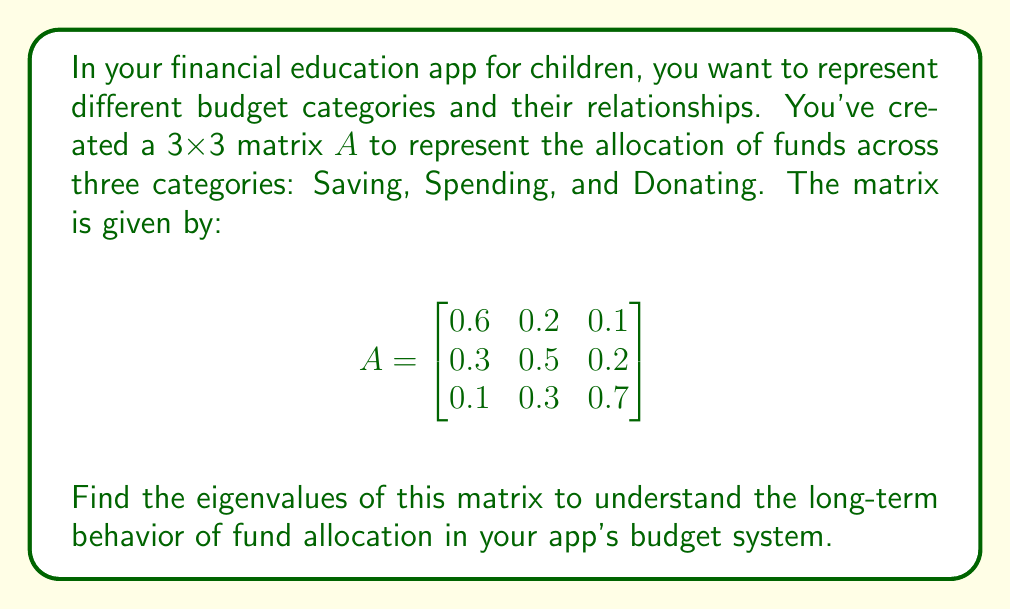Can you answer this question? To find the eigenvalues of matrix A, we need to solve the characteristic equation:

$$det(A - \lambda I) = 0$$

Where $\lambda$ represents the eigenvalues and I is the 3x3 identity matrix.

Step 1: Set up the characteristic equation:
$$\begin{vmatrix}
0.6 - \lambda & 0.2 & 0.1 \\
0.3 & 0.5 - \lambda & 0.2 \\
0.1 & 0.3 & 0.7 - \lambda
\end{vmatrix} = 0$$

Step 2: Expand the determinant:
$$(0.6 - \lambda)[(0.5 - \lambda)(0.7 - \lambda) - 0.06] - 0.2[0.3(0.7 - \lambda) - 0.02] + 0.1[0.3(0.5 - \lambda) - 0.06] = 0$$

Step 3: Simplify:
$$-\lambda^3 + 1.8\lambda^2 - 0.98\lambda + 0.16 = 0$$

Step 4: Solve the cubic equation. This can be done using the cubic formula or numerical methods. Using a computer algebra system, we find the roots:

$\lambda_1 \approx 1$
$\lambda_2 \approx 0.5$
$\lambda_3 \approx 0.3$

These are the eigenvalues of the matrix A.
Answer: $\lambda_1 = 1$, $\lambda_2 = 0.5$, $\lambda_3 = 0.3$ 